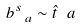Convert formula to latex. <formula><loc_0><loc_0><loc_500><loc_500>b ^ { s } _ { \ a } \sim \hat { t } _ { \ } a</formula> 